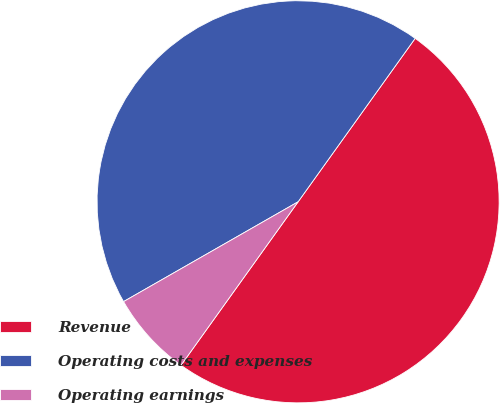Convert chart to OTSL. <chart><loc_0><loc_0><loc_500><loc_500><pie_chart><fcel>Revenue<fcel>Operating costs and expenses<fcel>Operating earnings<nl><fcel>50.0%<fcel>43.16%<fcel>6.84%<nl></chart> 